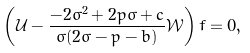Convert formula to latex. <formula><loc_0><loc_0><loc_500><loc_500>\left ( \mathcal { U } - \frac { - 2 \sigma ^ { 2 } + 2 p \sigma + c } { \sigma ( 2 \sigma - p - b ) } \mathcal { W } \right ) f = 0 ,</formula> 